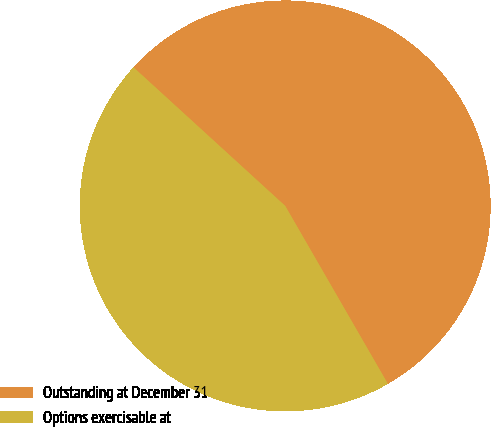<chart> <loc_0><loc_0><loc_500><loc_500><pie_chart><fcel>Outstanding at December 31<fcel>Options exercisable at<nl><fcel>54.89%<fcel>45.11%<nl></chart> 